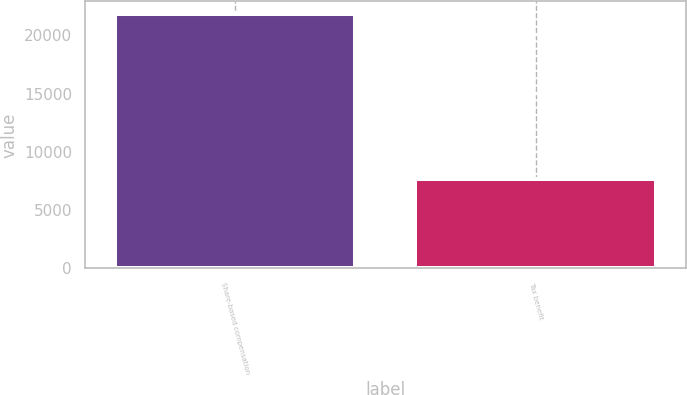Convert chart. <chart><loc_0><loc_0><loc_500><loc_500><bar_chart><fcel>Share-based compensation<fcel>Tax benefit<nl><fcel>21836<fcel>7643<nl></chart> 